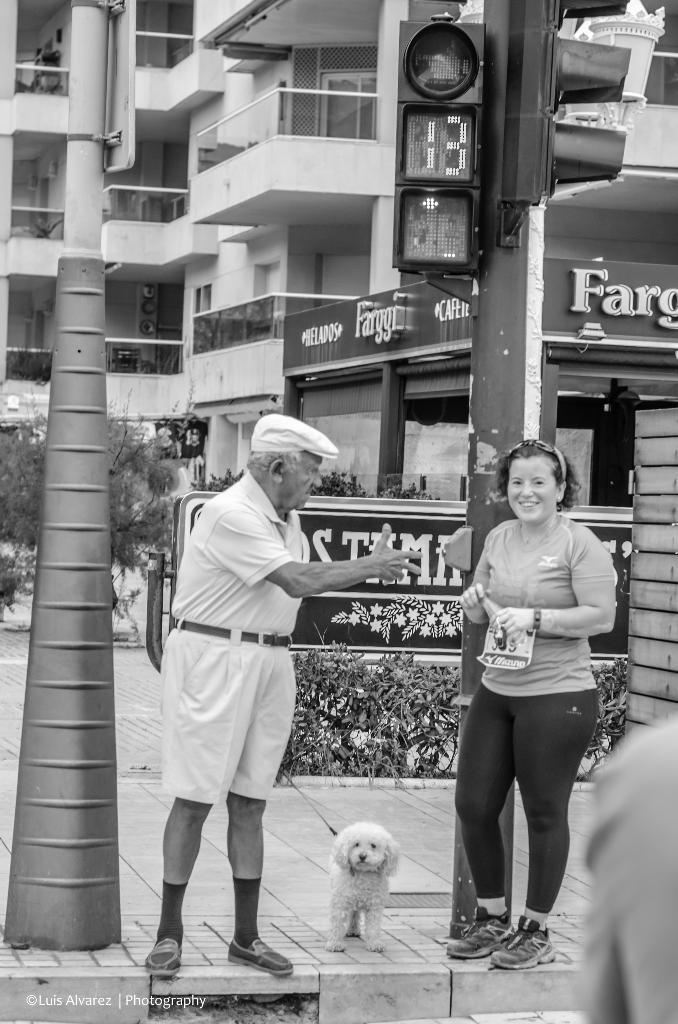Can you describe this image briefly? Here a man and woman are standing in between them there is a dog. Behind them there is a traffic signal,building and plants. 